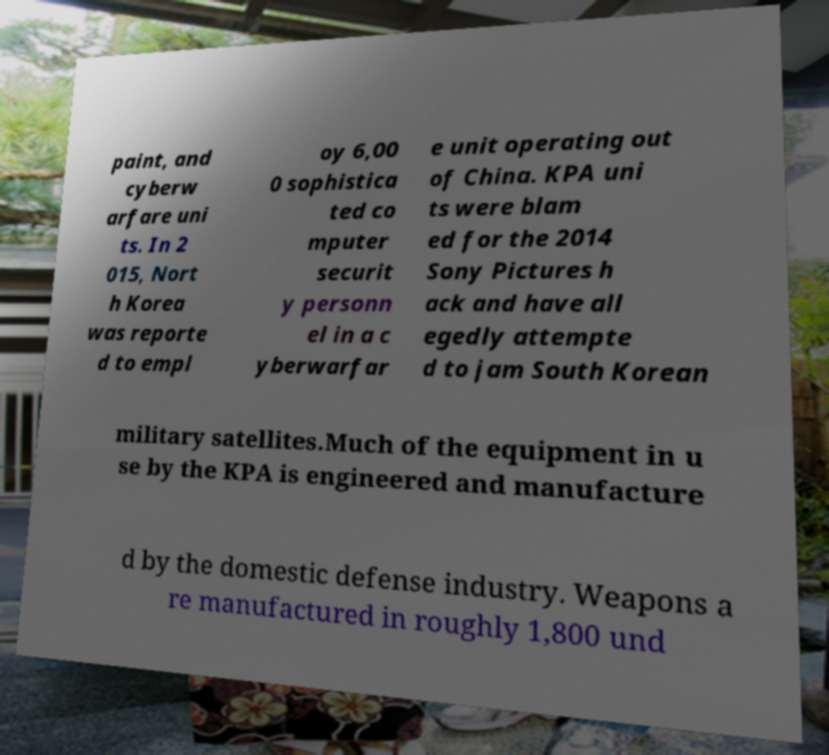Please identify and transcribe the text found in this image. paint, and cyberw arfare uni ts. In 2 015, Nort h Korea was reporte d to empl oy 6,00 0 sophistica ted co mputer securit y personn el in a c yberwarfar e unit operating out of China. KPA uni ts were blam ed for the 2014 Sony Pictures h ack and have all egedly attempte d to jam South Korean military satellites.Much of the equipment in u se by the KPA is engineered and manufacture d by the domestic defense industry. Weapons a re manufactured in roughly 1,800 und 